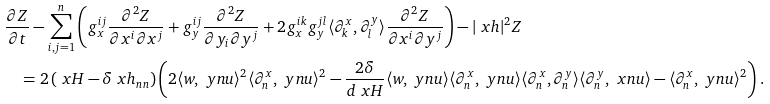Convert formula to latex. <formula><loc_0><loc_0><loc_500><loc_500>& \frac { \partial Z } { \partial t } - \sum _ { i , j = 1 } ^ { n } \left ( g _ { x } ^ { i j } \frac { \partial ^ { 2 } Z } { \partial x ^ { i } \partial x ^ { j } } + g _ { y } ^ { i j } \frac { \partial ^ { 2 } Z } { \partial y _ { i } \partial y ^ { j } } + 2 g _ { x } ^ { i k } g _ { y } ^ { j l } \langle \partial ^ { x } _ { k } , \partial ^ { y } _ { l } \rangle \frac { \partial ^ { 2 } Z } { \partial x ^ { i } \partial y ^ { j } } \right ) - | \ x h | ^ { 2 } Z \\ & \quad = 2 \left ( \ x H - \delta \ x h _ { n n } \right ) \left ( 2 \langle w , \ y n u \rangle ^ { 2 } \langle \partial ^ { x } _ { n } , \ y n u \rangle ^ { 2 } - \frac { 2 \delta } { d \ x H } \langle w , \ y n u \rangle \langle \partial ^ { x } _ { n } , \ y n u \rangle \langle \partial ^ { x } _ { n } , \partial ^ { y } _ { n } \rangle \langle \partial ^ { y } _ { n } , \ x n u \rangle - \langle \partial ^ { x } _ { n } , \ y n u \rangle ^ { 2 } \right ) .</formula> 